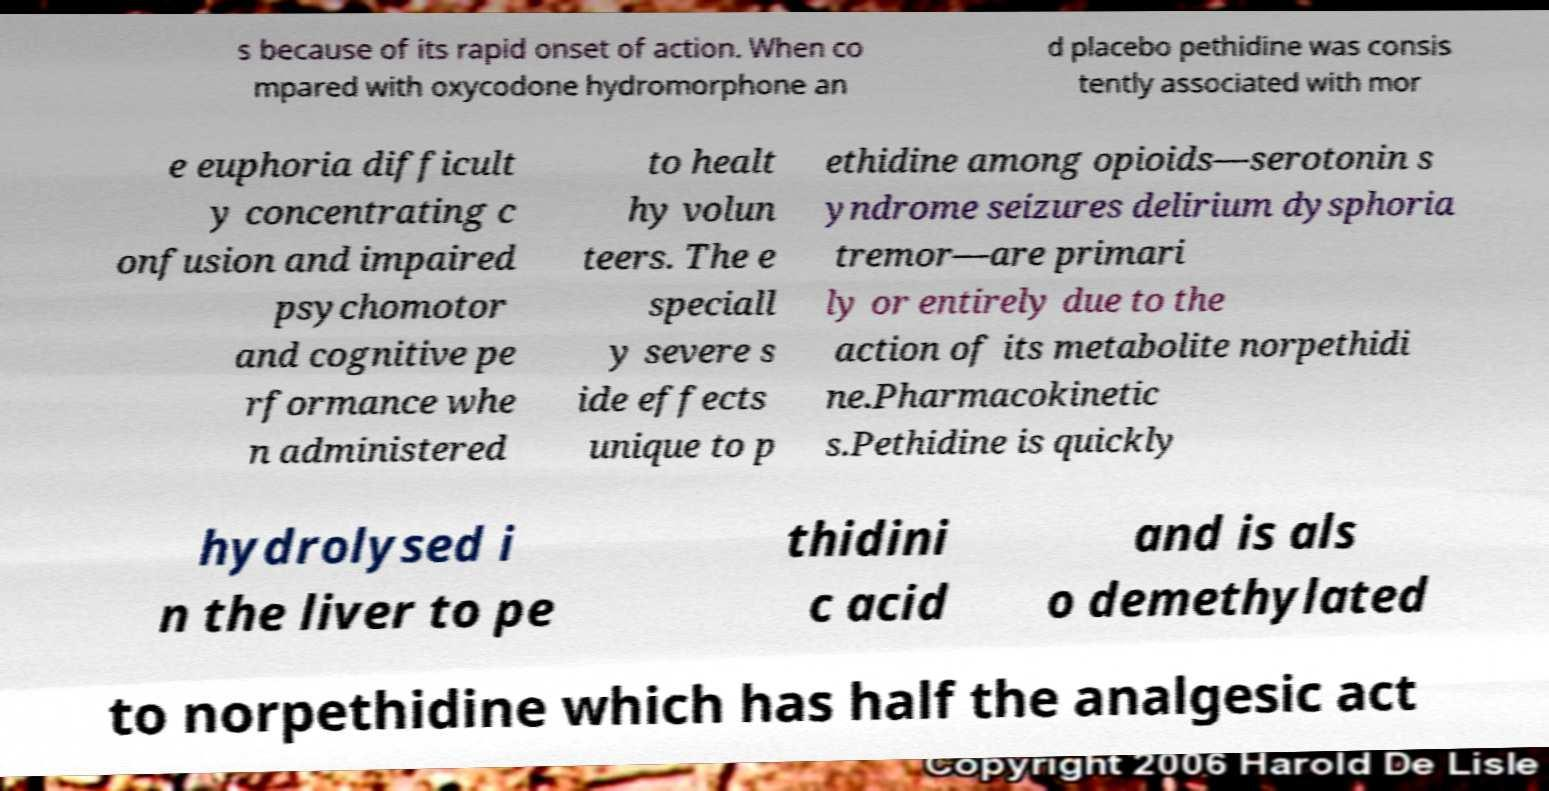For documentation purposes, I need the text within this image transcribed. Could you provide that? s because of its rapid onset of action. When co mpared with oxycodone hydromorphone an d placebo pethidine was consis tently associated with mor e euphoria difficult y concentrating c onfusion and impaired psychomotor and cognitive pe rformance whe n administered to healt hy volun teers. The e speciall y severe s ide effects unique to p ethidine among opioids—serotonin s yndrome seizures delirium dysphoria tremor—are primari ly or entirely due to the action of its metabolite norpethidi ne.Pharmacokinetic s.Pethidine is quickly hydrolysed i n the liver to pe thidini c acid and is als o demethylated to norpethidine which has half the analgesic act 